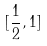<formula> <loc_0><loc_0><loc_500><loc_500>[ \frac { 1 } { 2 } , 1 ]</formula> 